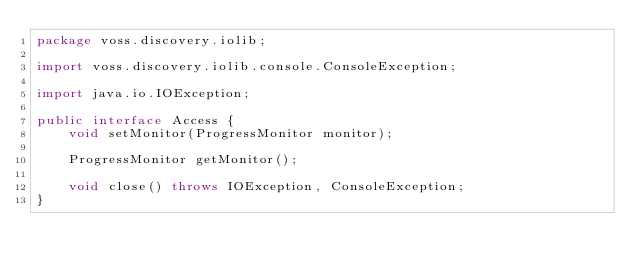<code> <loc_0><loc_0><loc_500><loc_500><_Java_>package voss.discovery.iolib;

import voss.discovery.iolib.console.ConsoleException;

import java.io.IOException;

public interface Access {
    void setMonitor(ProgressMonitor monitor);

    ProgressMonitor getMonitor();

    void close() throws IOException, ConsoleException;
}</code> 